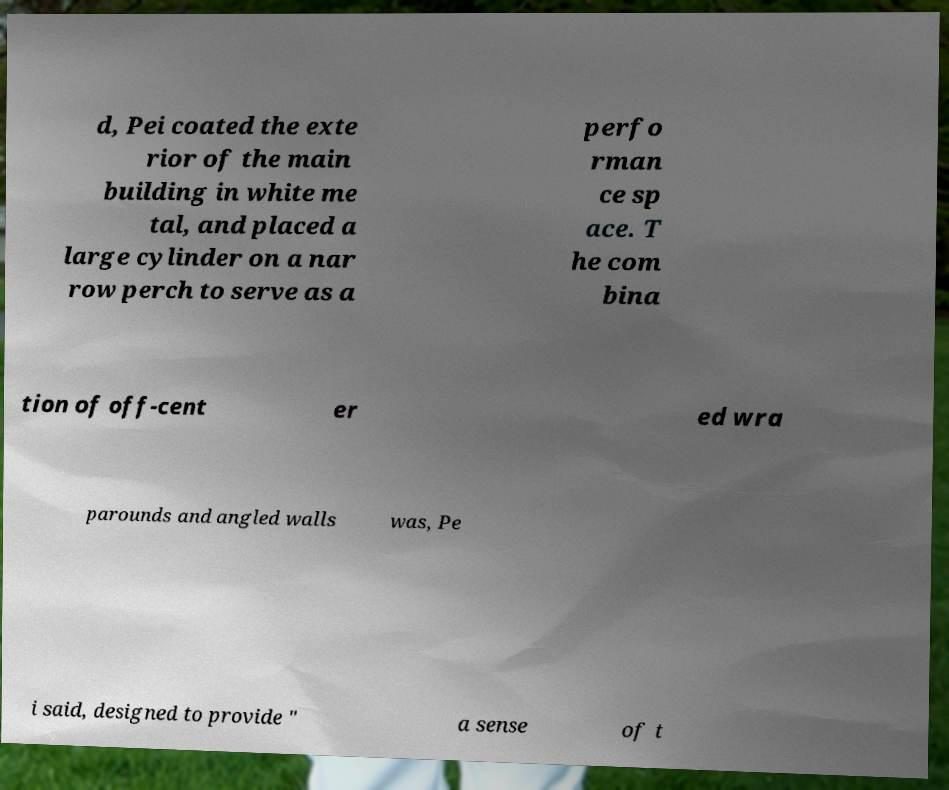Please identify and transcribe the text found in this image. d, Pei coated the exte rior of the main building in white me tal, and placed a large cylinder on a nar row perch to serve as a perfo rman ce sp ace. T he com bina tion of off-cent er ed wra parounds and angled walls was, Pe i said, designed to provide " a sense of t 